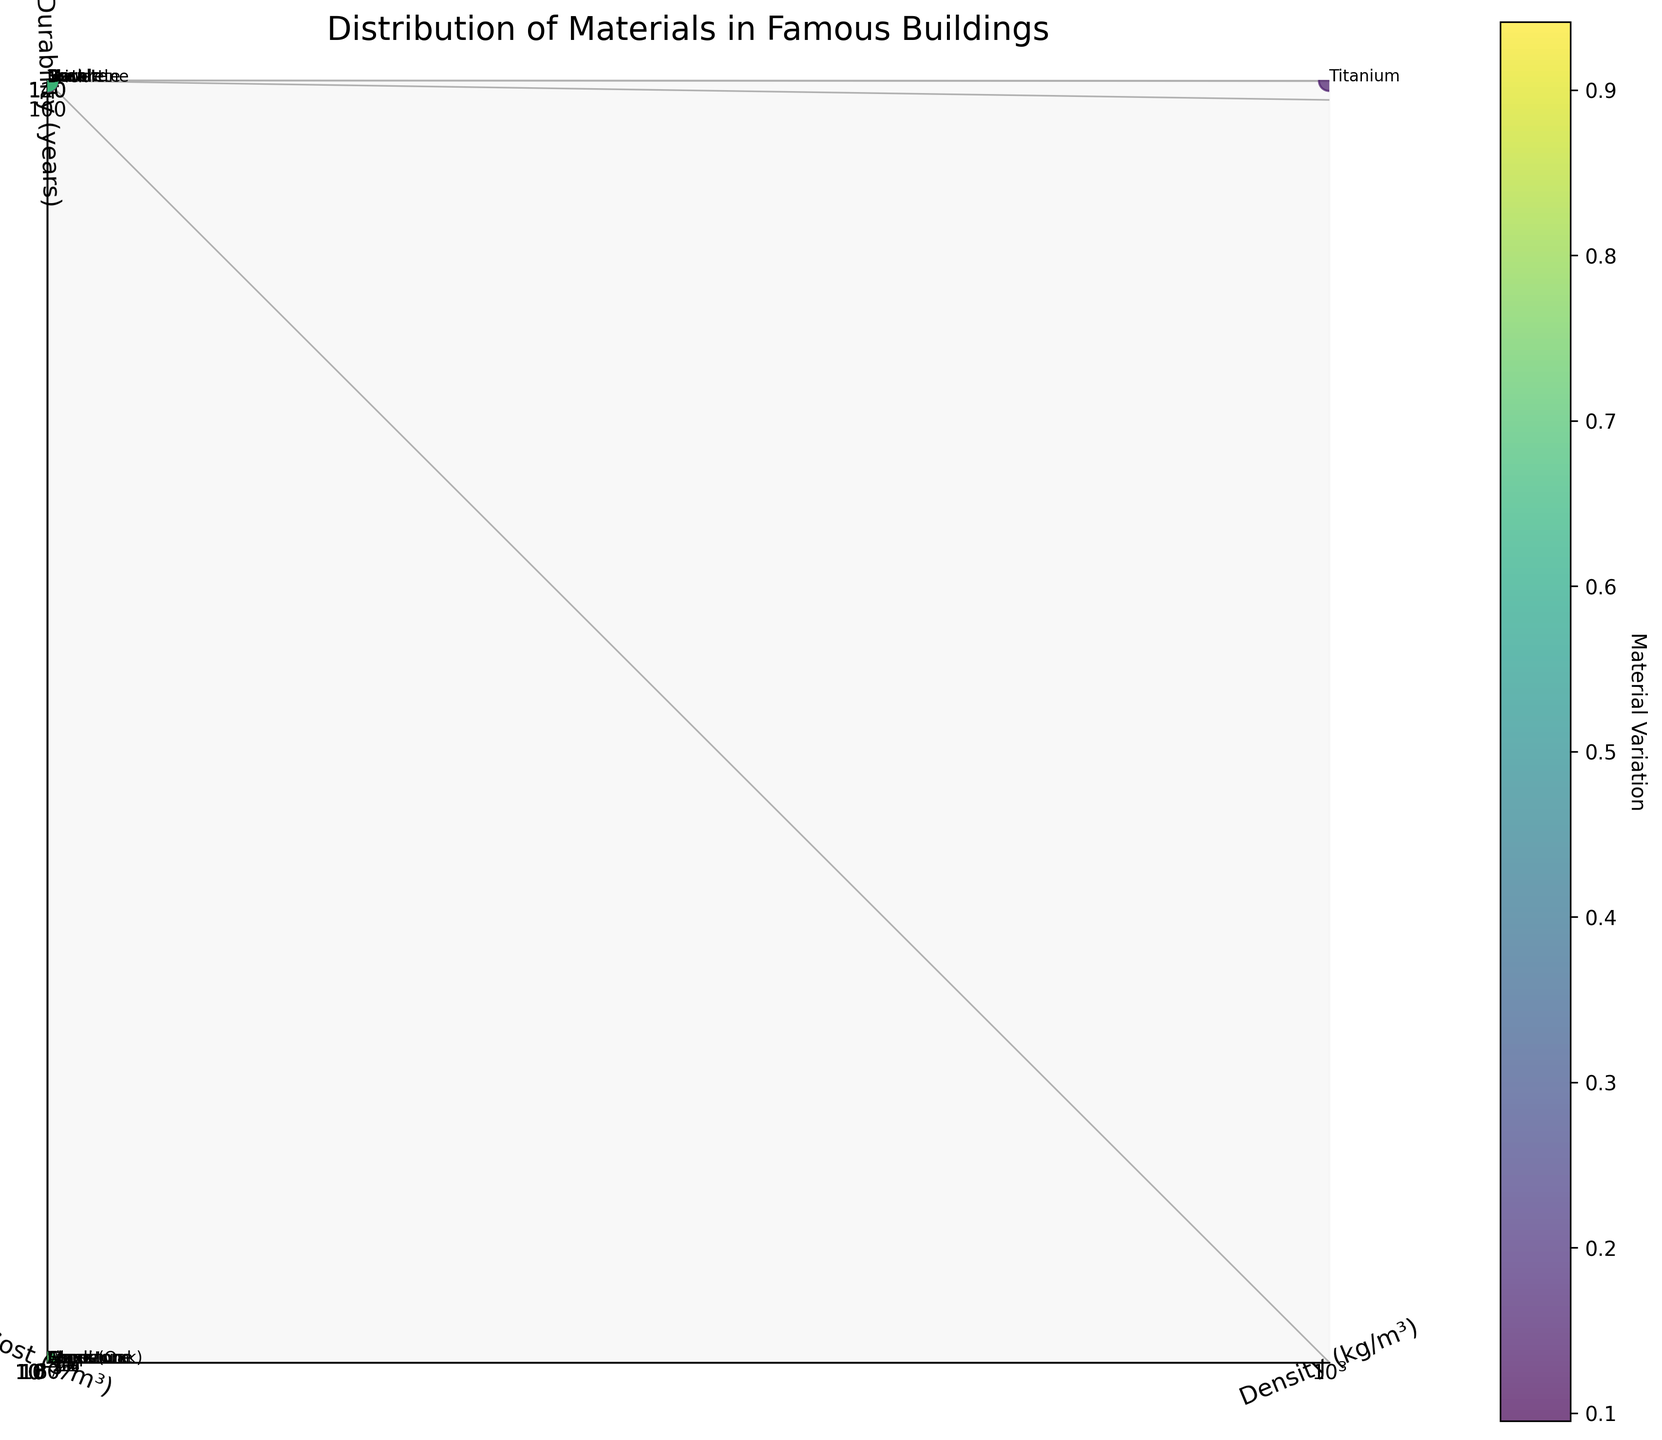what is the title of the plot? The title of the plot is written at the top of the figure. According to the plot, the title is "Distribution of Materials in Famous Buildings".
Answer: Distribution of Materials in Famous Buildings How many unique materials are displayed in the plot? By counting the number of data points in the scatter plot, one can determine the number of unique materials. Each material corresponds to a single data point in the plot.
Answer: 15 Which material has the highest durability? Observing the z-axis, which represents durability in years, and identifying the highest point, one can determine that Titanium has the highest durability.
Answer: Titanium What are the axis labels of the plot? The labels for each axis can be seen beside the respective axes: the x-axis is labeled 'Density (kg/m³)', the y-axis is labeled 'Cost ($/m³)', and the z-axis is labeled 'Durability (years)'.
Answer: Density (kg/m³), Cost ($/m³), Durability (years) Which materials are more durable: materials with higher density or lower density? By examining the scatter plot and correlating the density (x-axis) with durability (z-axis), it's evident that materials with higher density, such as Titanium, Basalt, and Slate, generally have higher durability.
Answer: Higher density Which material combines high cost and moderate density while also being durable? Analyzing the plot, look for data points positioned higher on the cost axis (y-axis) and mid-range on the density axis while ensuring they are higher on the durability axis too. Aluminum fits these criteria.
Answer: Aluminum What is the median cost of the materials represented in the plot? Arrange the cost values ($/m³) in ascending order, count the number of data points, and find the middle value. The sorted cost values are (200, 300, 400, 500, 600, 700, 800, 800, 900, 1000, 1200, 1500, 1800, 2500, 25000), so the median (middle) value is 800.
Answer: 800 Which material is the least dense but highly durable? By observing the points on the low end of the density (x-axis) and checking their positions on the high end of the durability (z-axis), it is evident that Wood (Oak) has the lowest density among the more durable materials.
Answer: Wood (Oak) Are there any materials plotted that have both low cost and high density? To find this, look at the lower part of the y-axis (low cost) and the higher part of the x-axis (high density). Concrete is one material meeting these criteria.
Answer: Concrete 